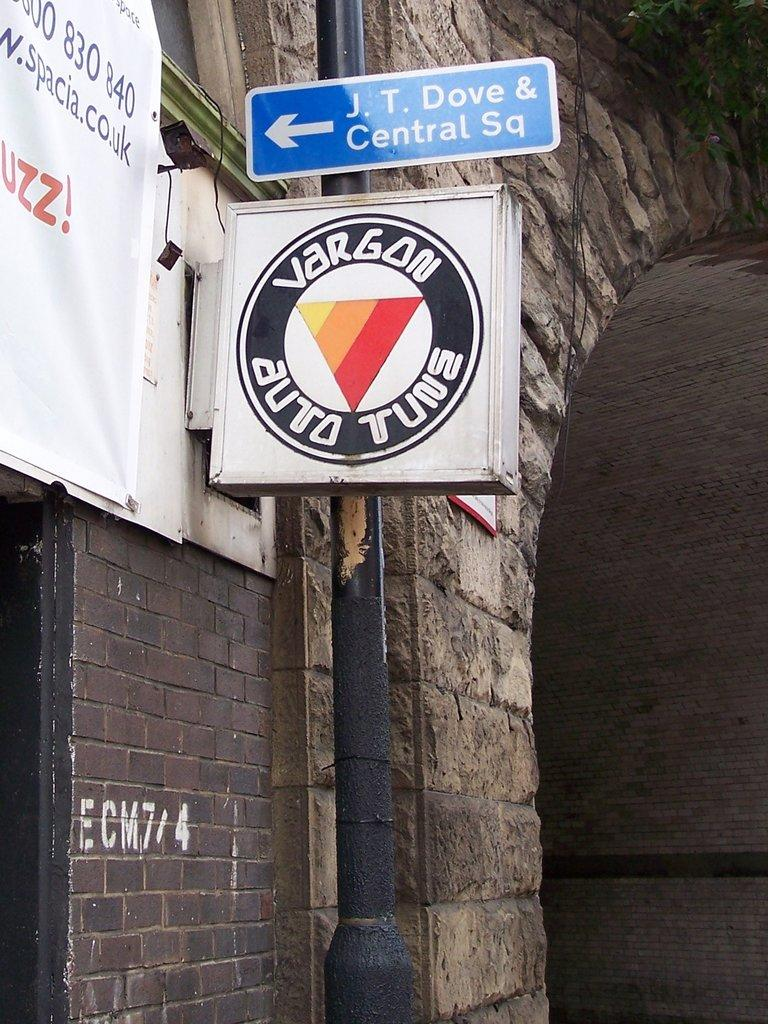<image>
Write a terse but informative summary of the picture. A brick and stone building with a blue sign for J.T. Dove & Central Square. 